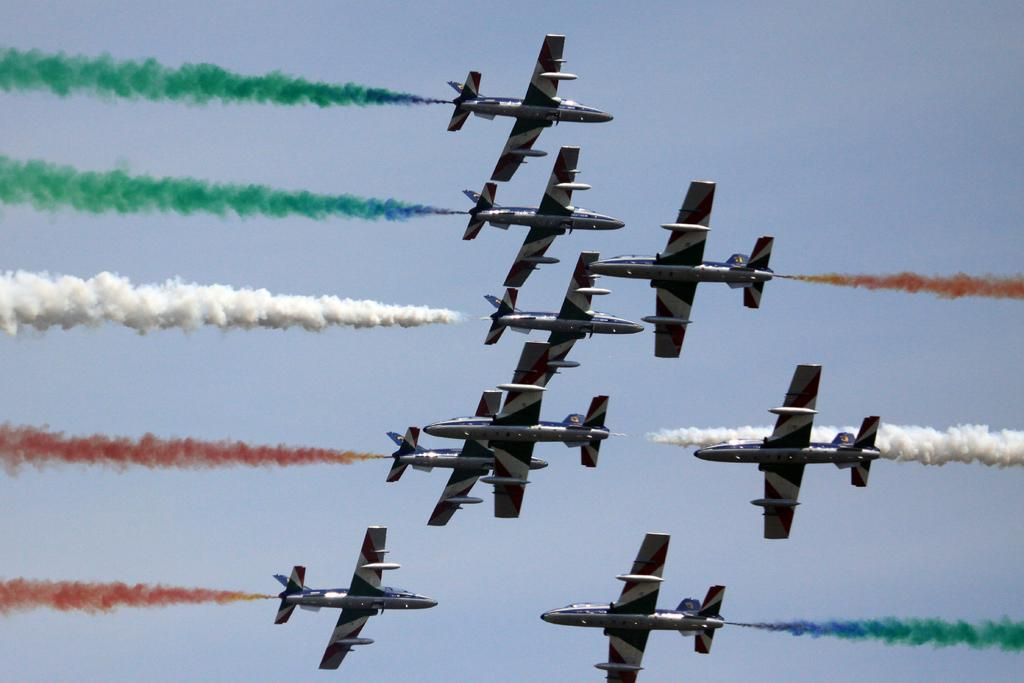What is the main subject in the center of the image? There are aircraft in the center of the image. Can you describe any other elements in the image? Yes, a dog is coming out in the image. What can be seen in the background of the image? There is sky visible in the background of the image. What type of drug is the dog carrying in the image? There is no drug present in the image; it features aircraft and a dog. Can you tell me who the dog's partner is in the image? There is no partner mentioned or depicted in the image; it only shows a dog and aircraft. 